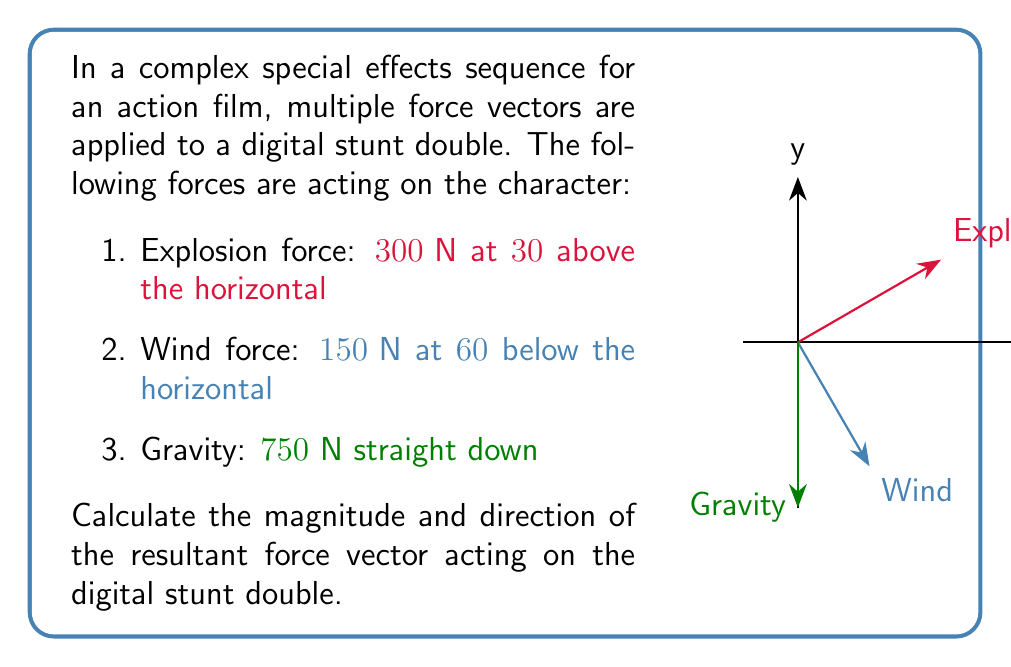Show me your answer to this math problem. Let's solve this problem step by step:

1) First, we need to break down each force into its x and y components:

   Explosion force:
   $F_{ex} = 300 \cos 30° = 300 \cdot \frac{\sqrt{3}}{2} = 150\sqrt{3} \text{ N}$
   $F_{ey} = 300 \sin 30° = 300 \cdot \frac{1}{2} = 150 \text{ N}$

   Wind force:
   $F_{wx} = 150 \cos 60° = 150 \cdot \frac{1}{2} = 75 \text{ N}$
   $F_{wy} = -150 \sin 60° = -150 \cdot \frac{\sqrt{3}}{2} = -75\sqrt{3} \text{ N}$

   Gravity:
   $F_{gx} = 0 \text{ N}$
   $F_{gy} = -750 \text{ N}$

2) Now, we sum up all the x components and all the y components:

   $F_x = F_{ex} + F_{wx} + F_{gx} = 150\sqrt{3} + 75 + 0 = 150\sqrt{3} + 75 \text{ N}$
   $F_y = F_{ey} + F_{wy} + F_{gy} = 150 - 75\sqrt{3} - 750 = -75\sqrt{3} - 600 \text{ N}$

3) The magnitude of the resultant force can be calculated using the Pythagorean theorem:

   $F = \sqrt{F_x^2 + F_y^2} = \sqrt{(150\sqrt{3} + 75)^2 + (-75\sqrt{3} - 600)^2} \text{ N}$

4) The direction of the resultant force can be found using the arctangent function:

   $\theta = \arctan(\frac{F_y}{F_x}) = \arctan(\frac{-75\sqrt{3} - 600}{150\sqrt{3} + 75})$

5) Calculate the final values:

   $F \approx 825.96 \text{ N}$
   $\theta \approx -71.57°$ (or $288.43°$ if measuring counterclockwise from the positive x-axis)
Answer: The resultant force is approximately 826 N at an angle of 71.6° below the horizontal. 